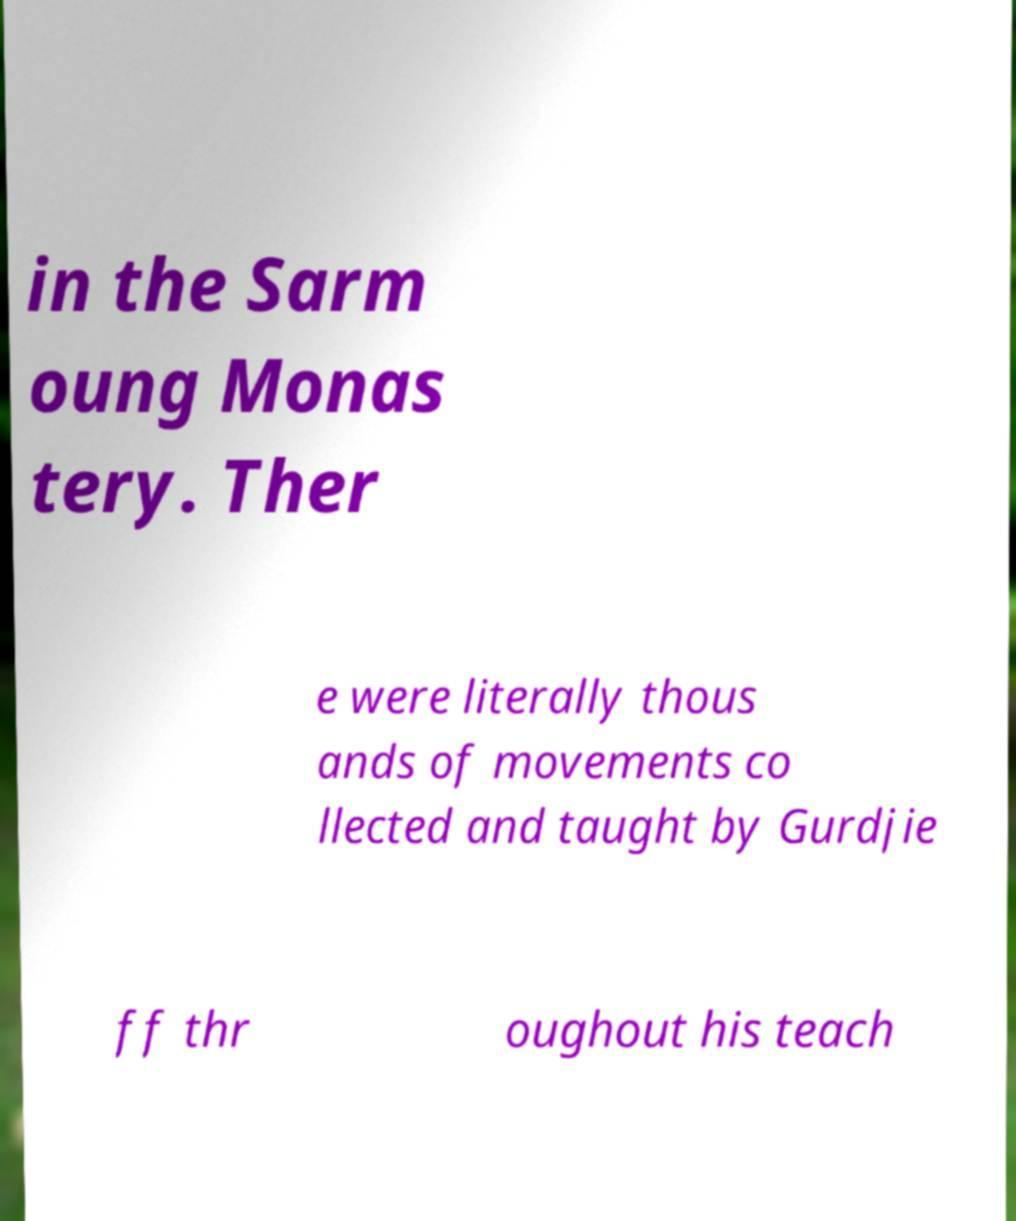Can you accurately transcribe the text from the provided image for me? in the Sarm oung Monas tery. Ther e were literally thous ands of movements co llected and taught by Gurdjie ff thr oughout his teach 